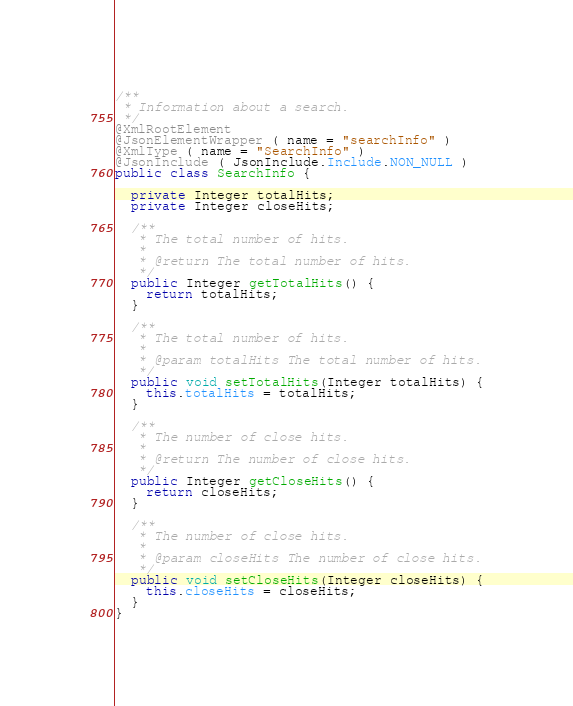<code> <loc_0><loc_0><loc_500><loc_500><_Java_>/**
 * Information about a search.
 */
@XmlRootElement
@JsonElementWrapper ( name = "searchInfo" )
@XmlType ( name = "SearchInfo" )
@JsonInclude ( JsonInclude.Include.NON_NULL )
public class SearchInfo {

  private Integer totalHits;
  private Integer closeHits;

  /**
   * The total number of hits.
   *
   * @return The total number of hits.
   */
  public Integer getTotalHits() {
    return totalHits;
  }

  /**
   * The total number of hits.
   *
   * @param totalHits The total number of hits.
   */
  public void setTotalHits(Integer totalHits) {
    this.totalHits = totalHits;
  }

  /**
   * The number of close hits.
   *
   * @return The number of close hits.
   */
  public Integer getCloseHits() {
    return closeHits;
  }

  /**
   * The number of close hits.
   *
   * @param closeHits The number of close hits.
   */
  public void setCloseHits(Integer closeHits) {
    this.closeHits = closeHits;
  }
}
</code> 